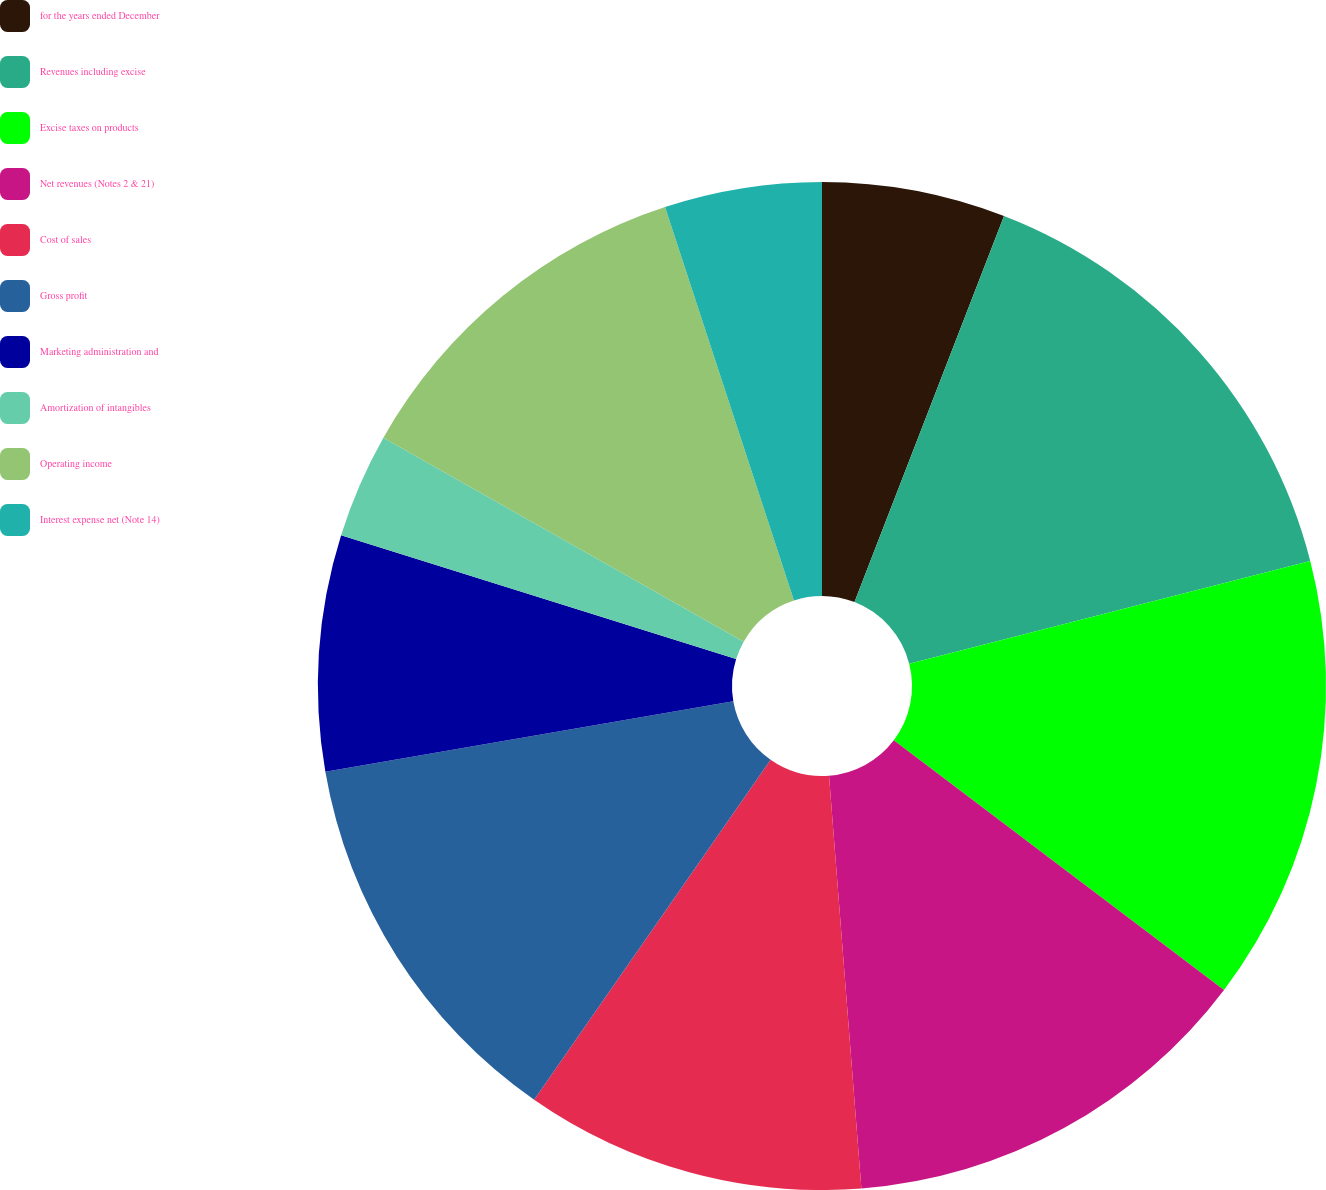Convert chart to OTSL. <chart><loc_0><loc_0><loc_500><loc_500><pie_chart><fcel>for the years ended December<fcel>Revenues including excise<fcel>Excise taxes on products<fcel>Net revenues (Notes 2 & 21)<fcel>Cost of sales<fcel>Gross profit<fcel>Marketing administration and<fcel>Amortization of intangibles<fcel>Operating income<fcel>Interest expense net (Note 14)<nl><fcel>5.88%<fcel>15.13%<fcel>14.29%<fcel>13.45%<fcel>10.92%<fcel>12.6%<fcel>7.56%<fcel>3.36%<fcel>11.76%<fcel>5.04%<nl></chart> 